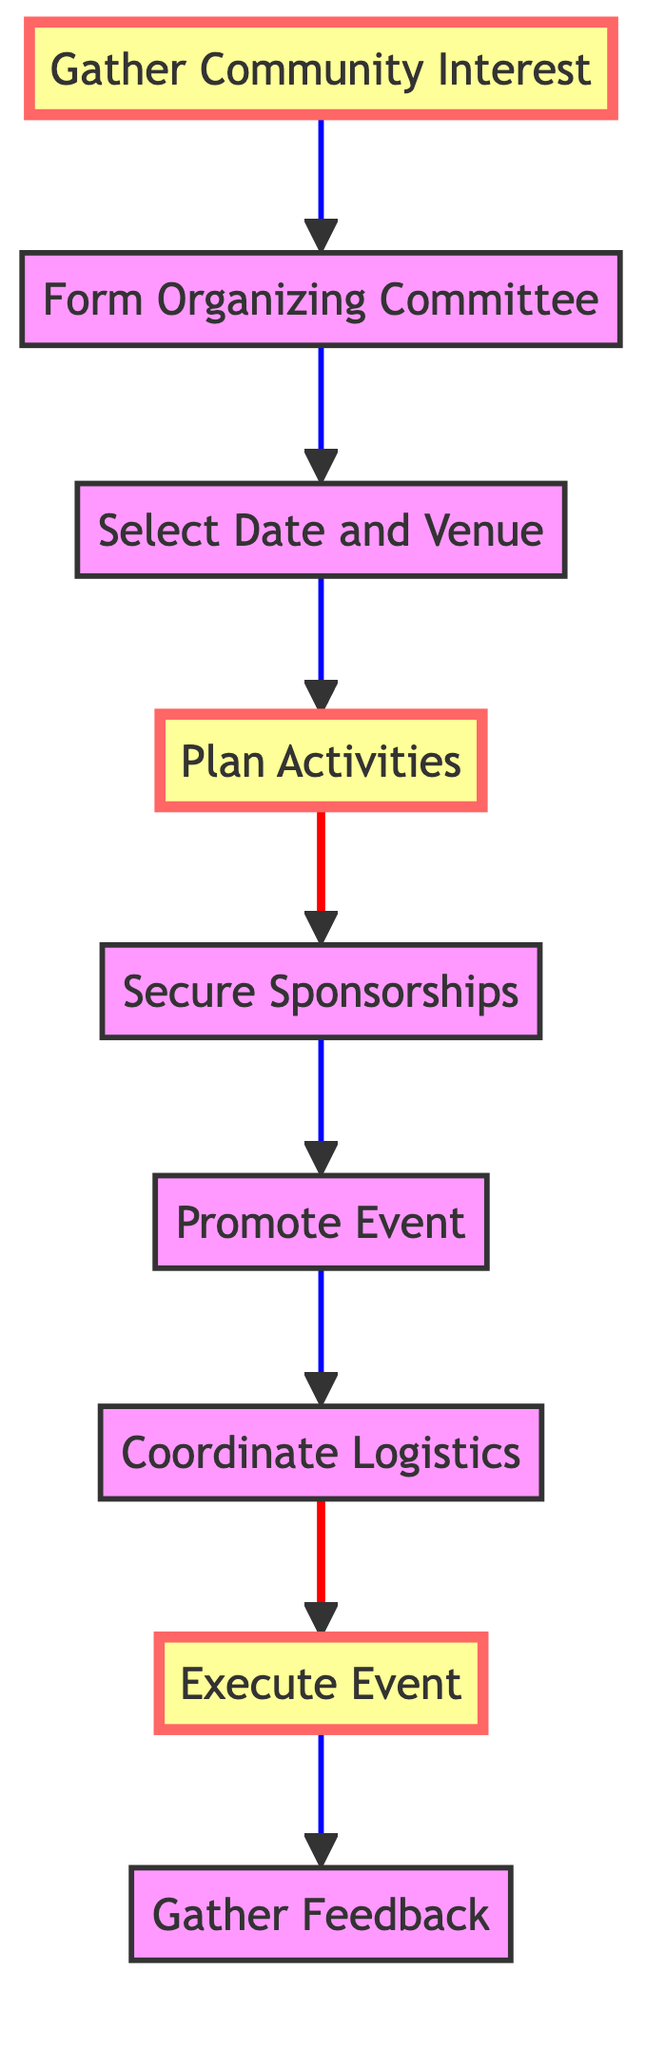What is the first step in organizing a community fitness event? The first step is to "Gather Community Interest," which involves surveying the local community to gauge interest.
Answer: Gather Community Interest How many main nodes are there in the flowchart? The flowchart contains a total of 9 main nodes that represent different steps in organizing the event.
Answer: 9 What is the last step shown in the diagram? The last step in the diagram is "Gather Feedback," which indicates collecting feedback from participants and volunteers post-event.
Answer: Gather Feedback Which step comes directly after "Plan Activities"? The step that comes directly after "Plan Activities" is "Secure Sponsorships."
Answer: Secure Sponsorships What color is the node for "Execute Event"? The node for "Execute Event" is colored in the default style, which is not highlighted.
Answer: Default What are the three highlighted steps in the diagram? The three highlighted steps are "Gather Community Interest," "Plan Activities," and "Execute Event."
Answer: Gather Community Interest, Plan Activities, Execute Event To which step does "Promote Event" connect? "Promote Event" connects to "Coordinate Logistics," indicating the flow of event organization.
Answer: Coordinate Logistics Why is "Select Date and Venue" important in the flowchart? It is important because it defines when and where the fitness event will take place, impacting all subsequent planning.
Answer: It sets the date and location What can be concluded if "Gather Feedback" is not included in the process? The absence of "Gather Feedback" would imply that there is no evaluation of the event’s success, making it difficult to plan for future events.
Answer: No evaluation of success How does the flow of the diagram progress? The flow of the diagram progresses upwards, indicating a sequence of steps to follow for organizing an event.
Answer: Upwards 